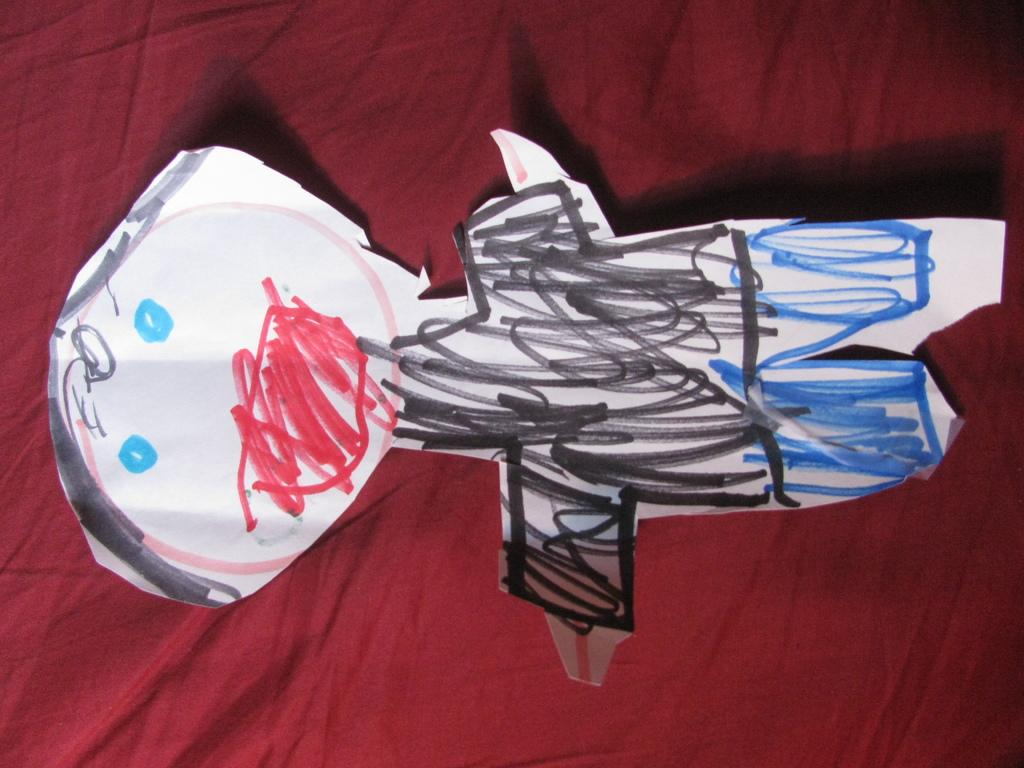What is depicted on the paper in the image? There is a drawing on a paper in the image. What color is the surface that the paper is on? The surface is maroon. How many zebras can be seen in the mist in the image? There are no zebras or mist present in the image; it only features a drawing on a paper and a maroon surface. 